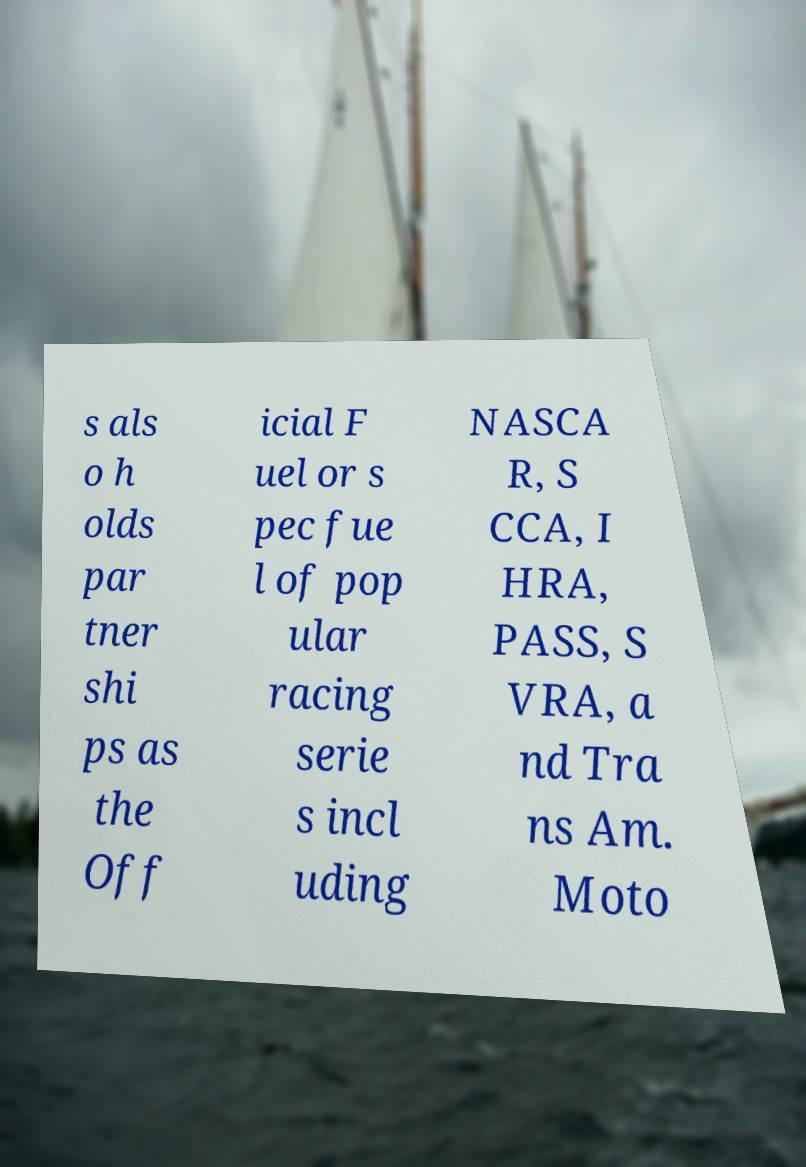Can you accurately transcribe the text from the provided image for me? s als o h olds par tner shi ps as the Off icial F uel or s pec fue l of pop ular racing serie s incl uding NASCA R, S CCA, I HRA, PASS, S VRA, a nd Tra ns Am. Moto 